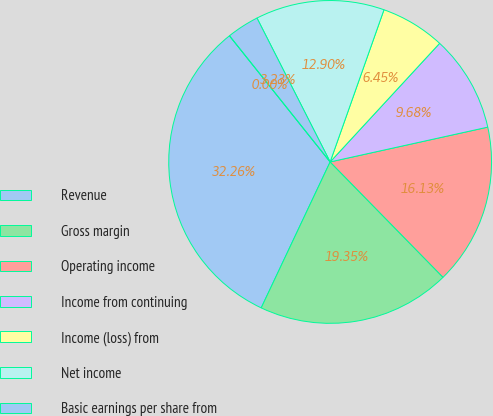Convert chart to OTSL. <chart><loc_0><loc_0><loc_500><loc_500><pie_chart><fcel>Revenue<fcel>Gross margin<fcel>Operating income<fcel>Income from continuing<fcel>Income (loss) from<fcel>Net income<fcel>Basic earnings per share from<fcel>Diluted earnings per share<nl><fcel>32.26%<fcel>19.35%<fcel>16.13%<fcel>9.68%<fcel>6.45%<fcel>12.9%<fcel>3.23%<fcel>0.0%<nl></chart> 